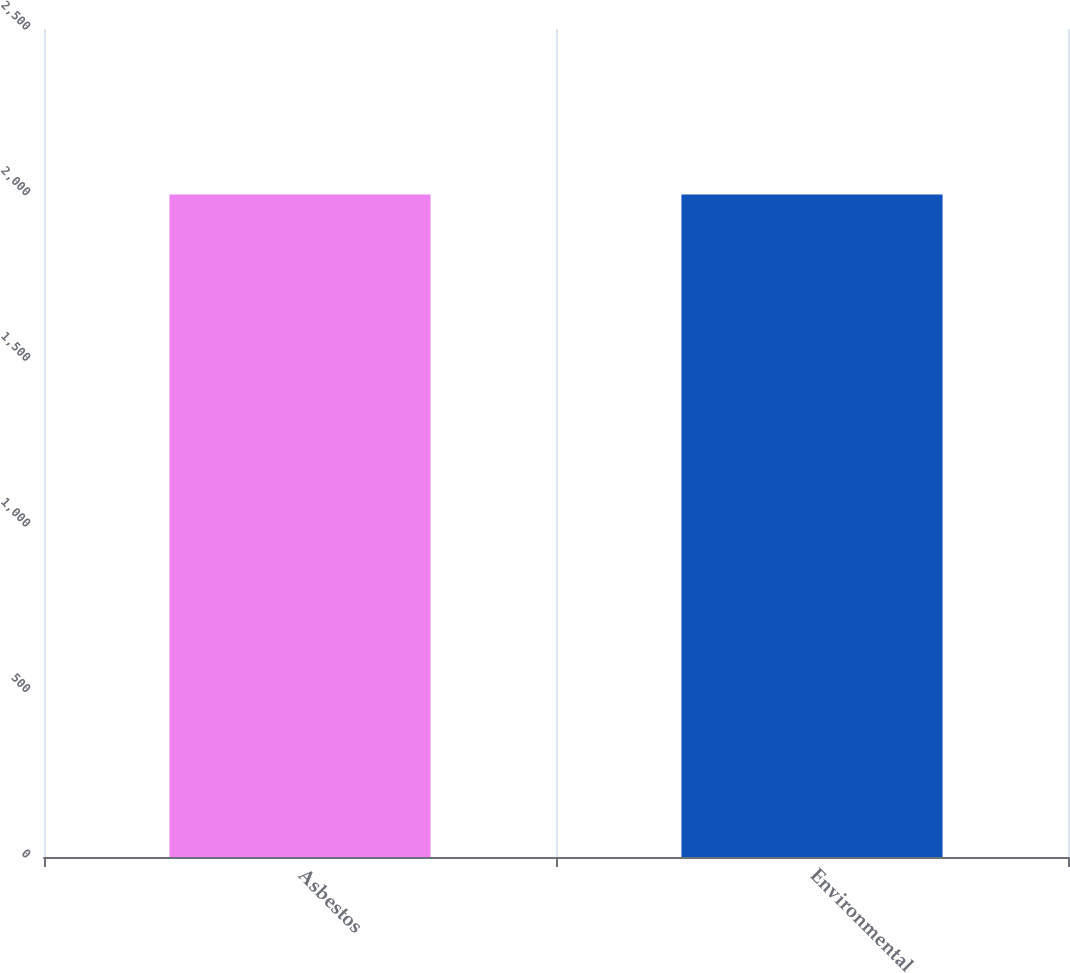Convert chart to OTSL. <chart><loc_0><loc_0><loc_500><loc_500><bar_chart><fcel>Asbestos<fcel>Environmental<nl><fcel>2000<fcel>2000.1<nl></chart> 